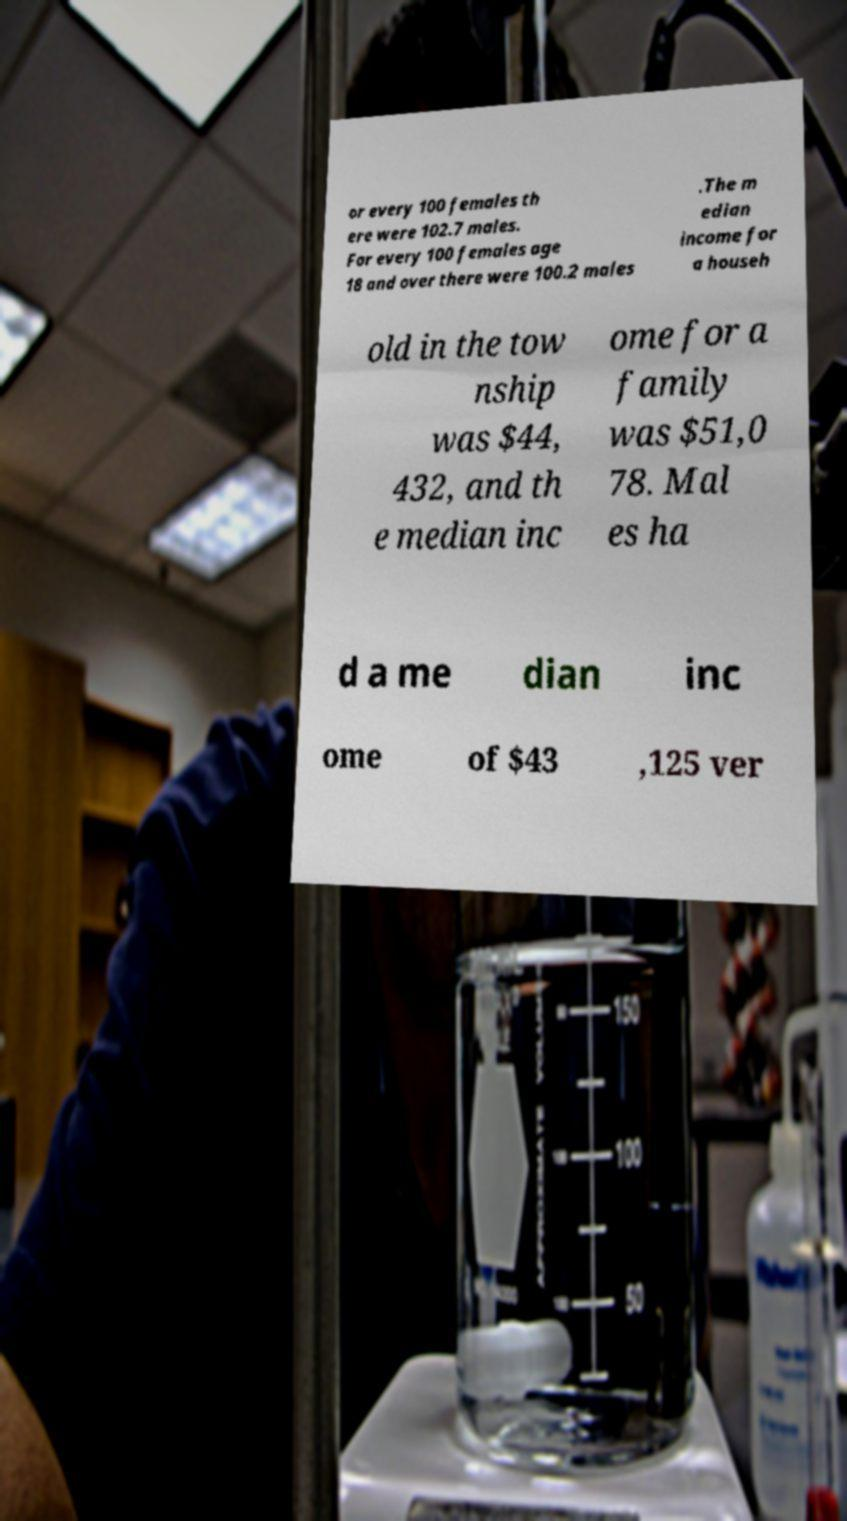Can you accurately transcribe the text from the provided image for me? or every 100 females th ere were 102.7 males. For every 100 females age 18 and over there were 100.2 males .The m edian income for a househ old in the tow nship was $44, 432, and th e median inc ome for a family was $51,0 78. Mal es ha d a me dian inc ome of $43 ,125 ver 